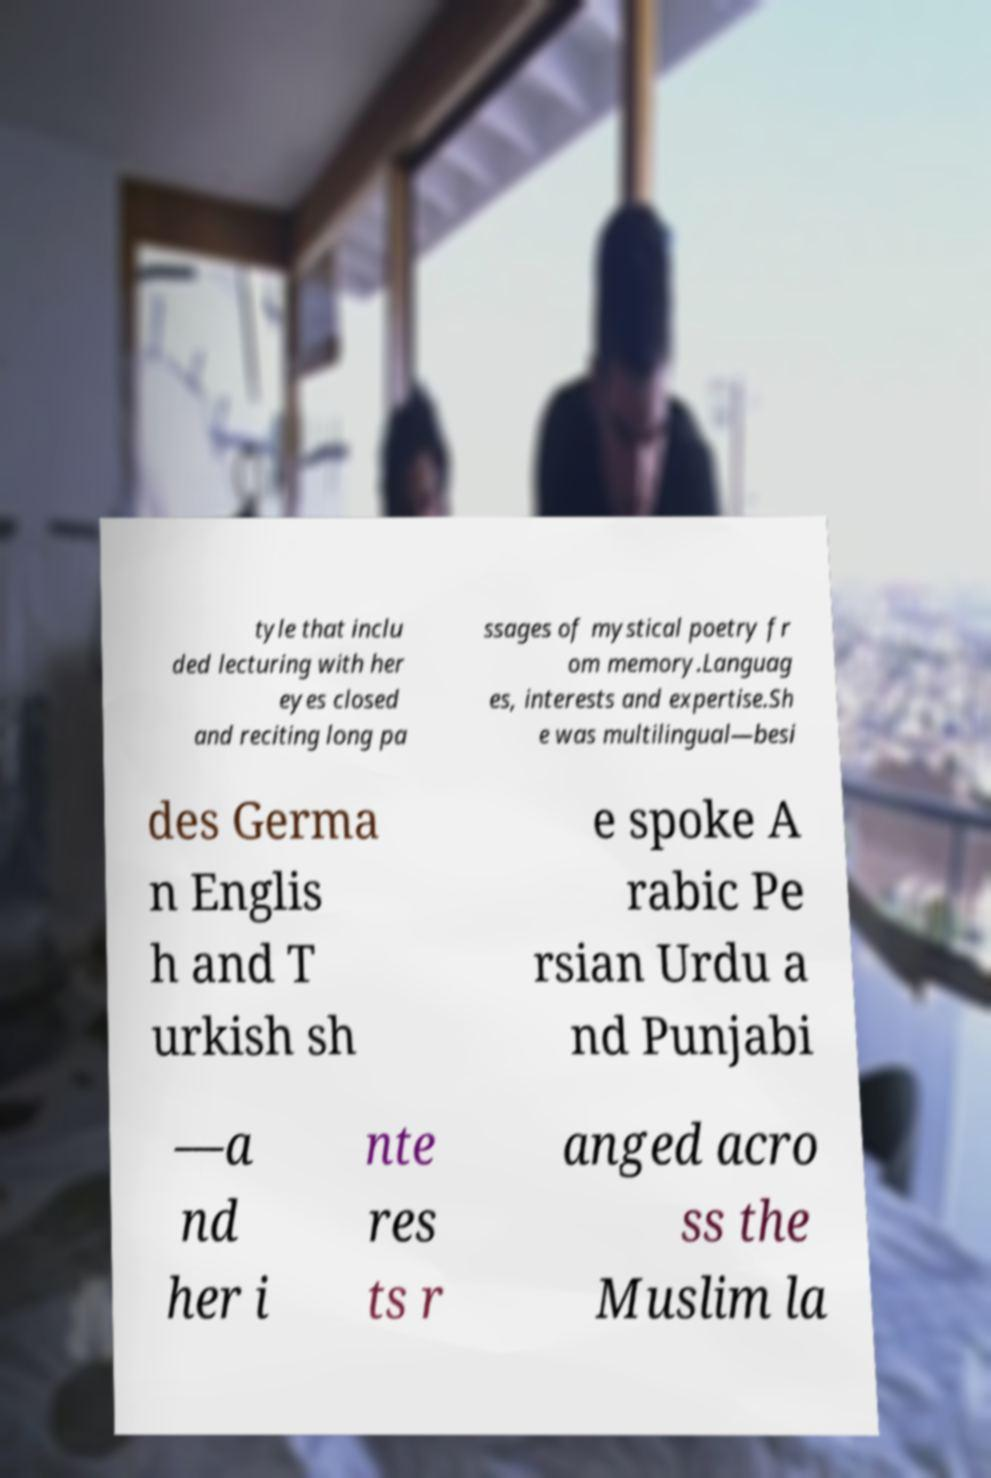Could you extract and type out the text from this image? tyle that inclu ded lecturing with her eyes closed and reciting long pa ssages of mystical poetry fr om memory.Languag es, interests and expertise.Sh e was multilingual—besi des Germa n Englis h and T urkish sh e spoke A rabic Pe rsian Urdu a nd Punjabi —a nd her i nte res ts r anged acro ss the Muslim la 